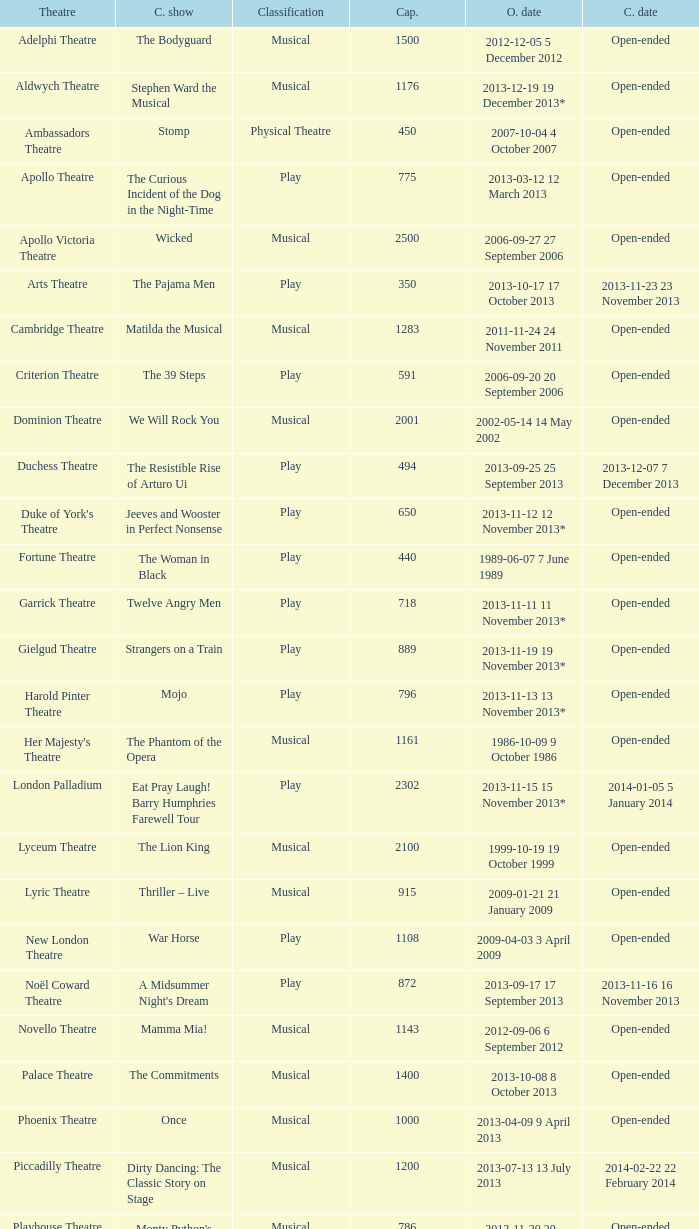What opening date has a capacity of 100? 2013-11-01 1 November 2013. 